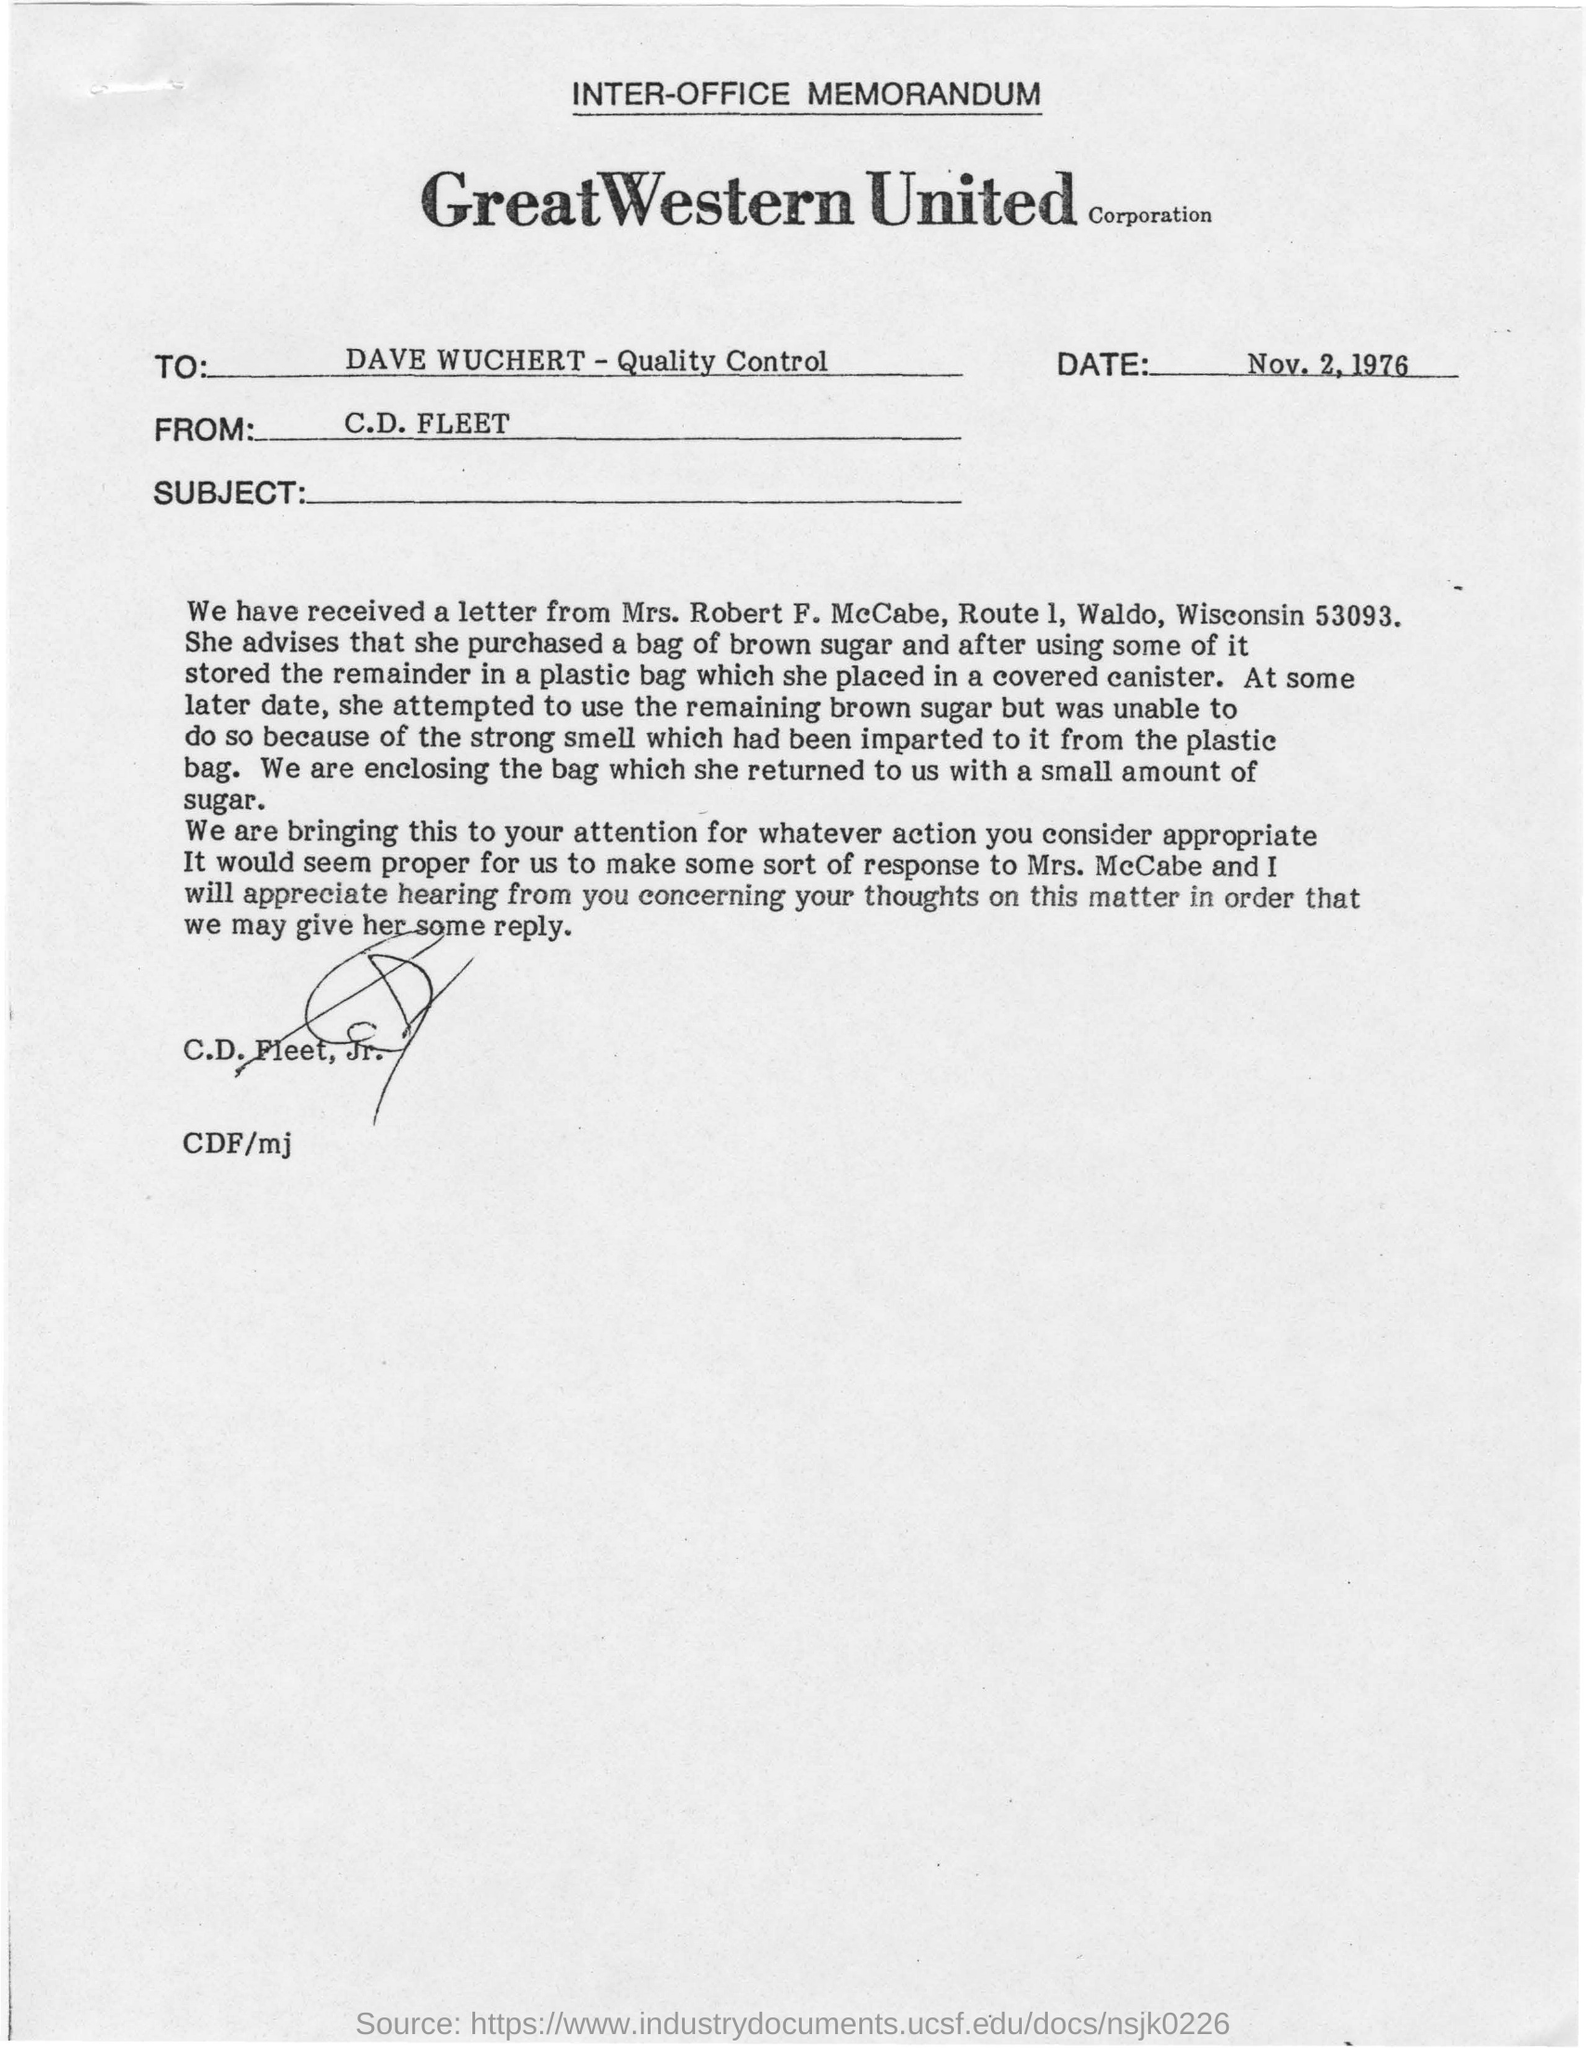Mention a couple of crucial points in this snapshot. The memorandum is from C.D. Fleet. The memorandum is addressed to Dave Wuchert, who is responsible for Quality Control. The memorandum is dated on November 2, 1976. 